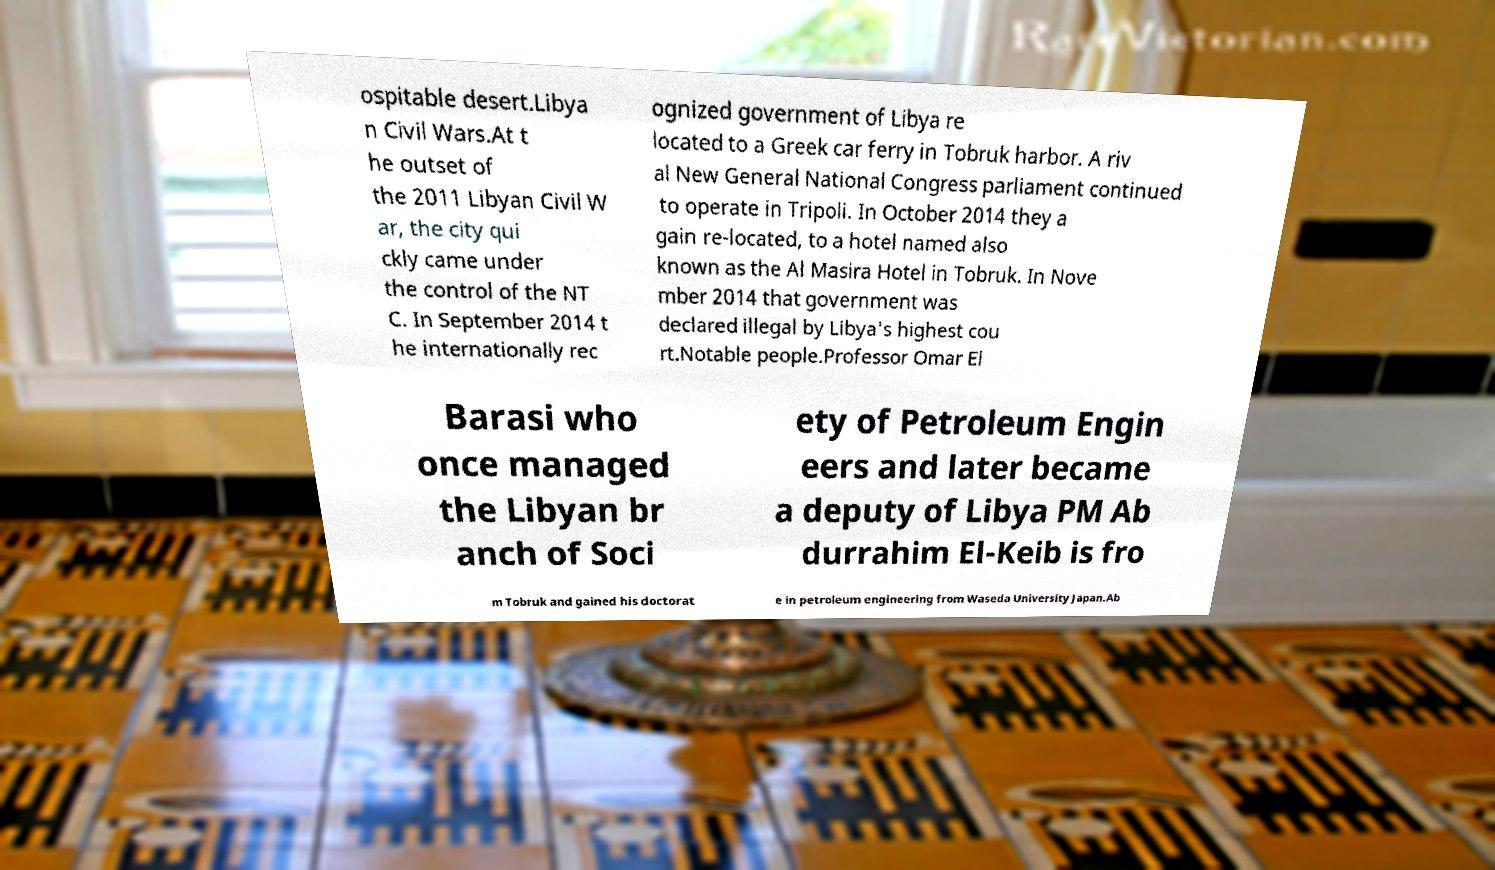I need the written content from this picture converted into text. Can you do that? ospitable desert.Libya n Civil Wars.At t he outset of the 2011 Libyan Civil W ar, the city qui ckly came under the control of the NT C. In September 2014 t he internationally rec ognized government of Libya re located to a Greek car ferry in Tobruk harbor. A riv al New General National Congress parliament continued to operate in Tripoli. In October 2014 they a gain re-located, to a hotel named also known as the Al Masira Hotel in Tobruk. In Nove mber 2014 that government was declared illegal by Libya's highest cou rt.Notable people.Professor Omar El Barasi who once managed the Libyan br anch of Soci ety of Petroleum Engin eers and later became a deputy of Libya PM Ab durrahim El-Keib is fro m Tobruk and gained his doctorat e in petroleum engineering from Waseda University Japan.Ab 